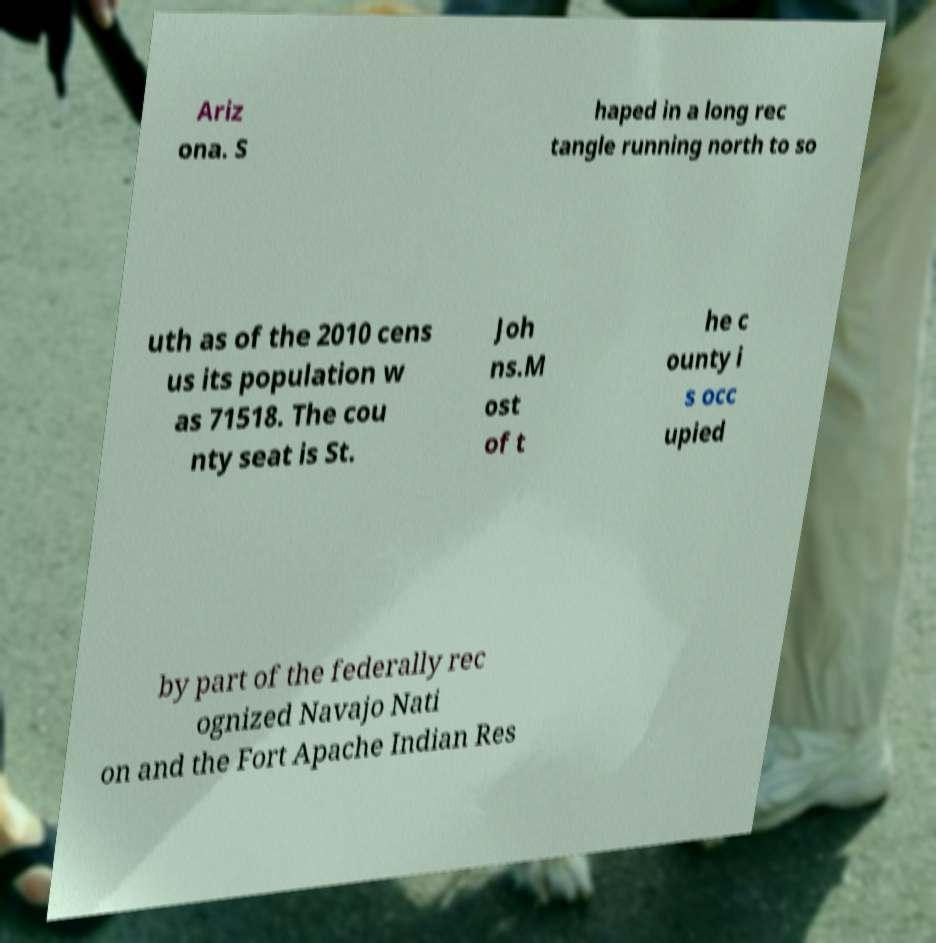Could you assist in decoding the text presented in this image and type it out clearly? Ariz ona. S haped in a long rec tangle running north to so uth as of the 2010 cens us its population w as 71518. The cou nty seat is St. Joh ns.M ost of t he c ounty i s occ upied by part of the federally rec ognized Navajo Nati on and the Fort Apache Indian Res 